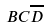Convert formula to latex. <formula><loc_0><loc_0><loc_500><loc_500>B C \overline { D }</formula> 